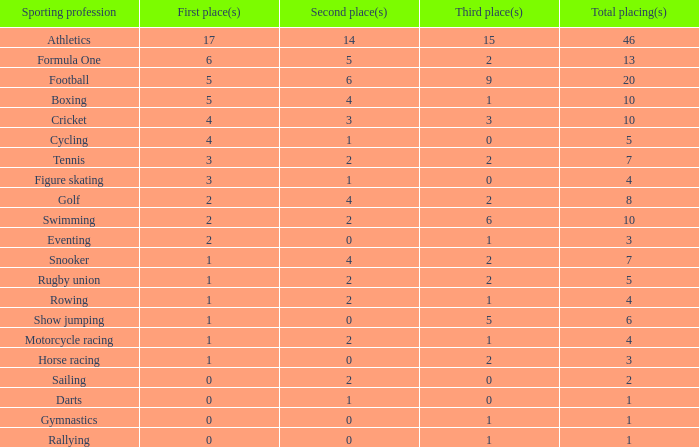Would you be able to parse every entry in this table? {'header': ['Sporting profession', 'First place(s)', 'Second place(s)', 'Third place(s)', 'Total placing(s)'], 'rows': [['Athletics', '17', '14', '15', '46'], ['Formula One', '6', '5', '2', '13'], ['Football', '5', '6', '9', '20'], ['Boxing', '5', '4', '1', '10'], ['Cricket', '4', '3', '3', '10'], ['Cycling', '4', '1', '0', '5'], ['Tennis', '3', '2', '2', '7'], ['Figure skating', '3', '1', '0', '4'], ['Golf', '2', '4', '2', '8'], ['Swimming', '2', '2', '6', '10'], ['Eventing', '2', '0', '1', '3'], ['Snooker', '1', '4', '2', '7'], ['Rugby union', '1', '2', '2', '5'], ['Rowing', '1', '2', '1', '4'], ['Show jumping', '1', '0', '5', '6'], ['Motorcycle racing', '1', '2', '1', '4'], ['Horse racing', '1', '0', '2', '3'], ['Sailing', '0', '2', '0', '2'], ['Darts', '0', '1', '0', '1'], ['Gymnastics', '0', '0', '1', '1'], ['Rallying', '0', '0', '1', '1']]} What is the count of 3rd place entries with precisely 8 total placings? 1.0. 